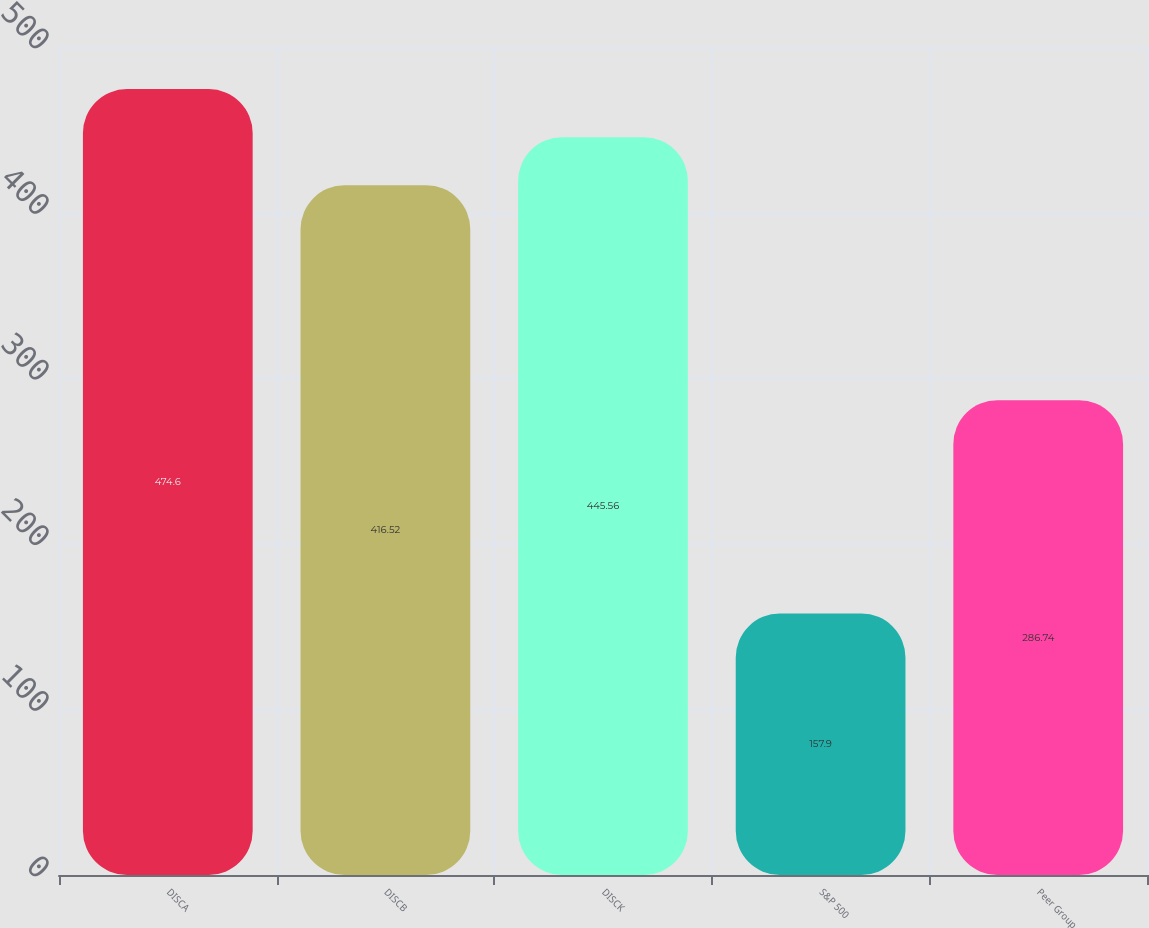<chart> <loc_0><loc_0><loc_500><loc_500><bar_chart><fcel>DISCA<fcel>DISCB<fcel>DISCK<fcel>S&P 500<fcel>Peer Group<nl><fcel>474.6<fcel>416.52<fcel>445.56<fcel>157.9<fcel>286.74<nl></chart> 